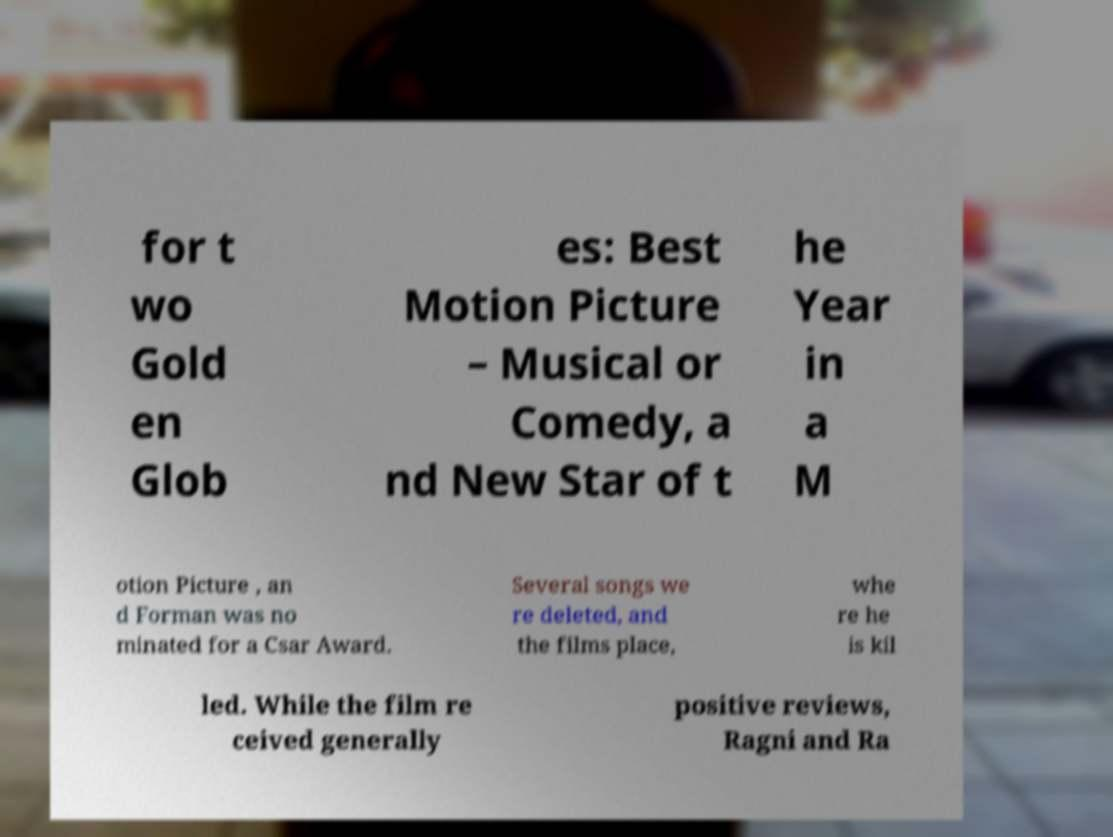Please read and relay the text visible in this image. What does it say? for t wo Gold en Glob es: Best Motion Picture – Musical or Comedy, a nd New Star of t he Year in a M otion Picture , an d Forman was no minated for a Csar Award. Several songs we re deleted, and the films place, whe re he is kil led. While the film re ceived generally positive reviews, Ragni and Ra 